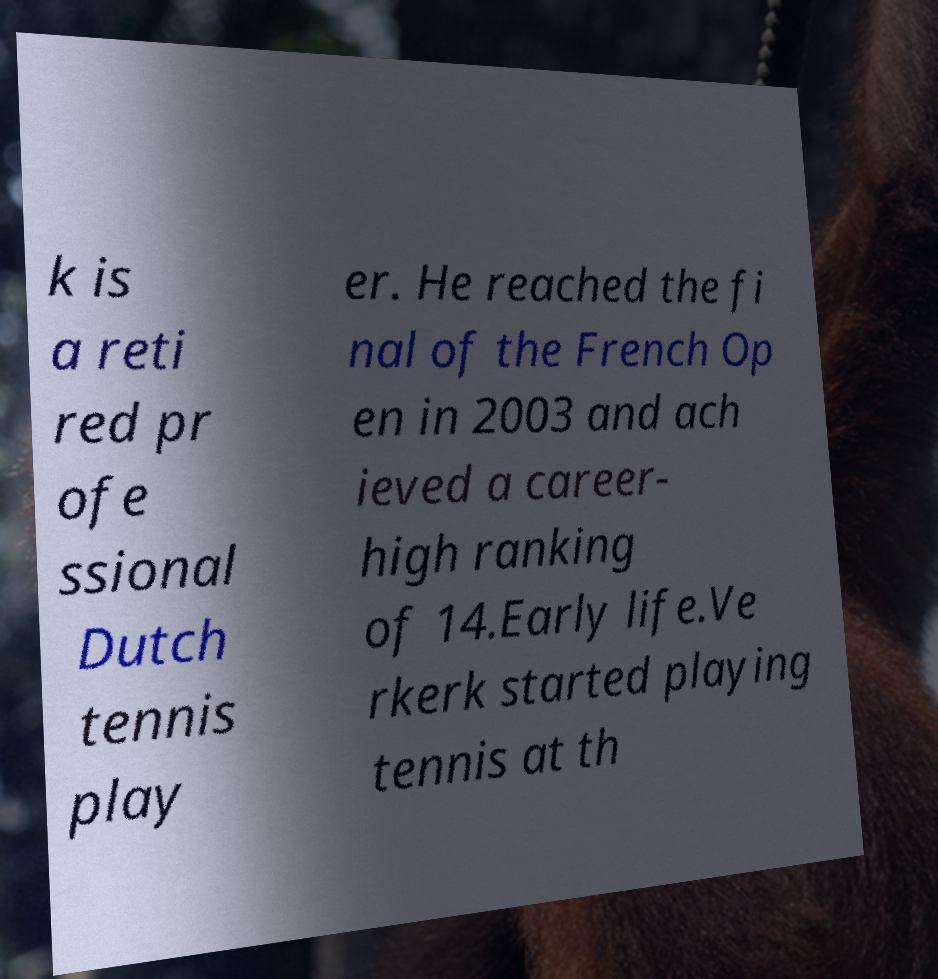Please identify and transcribe the text found in this image. k is a reti red pr ofe ssional Dutch tennis play er. He reached the fi nal of the French Op en in 2003 and ach ieved a career- high ranking of 14.Early life.Ve rkerk started playing tennis at th 